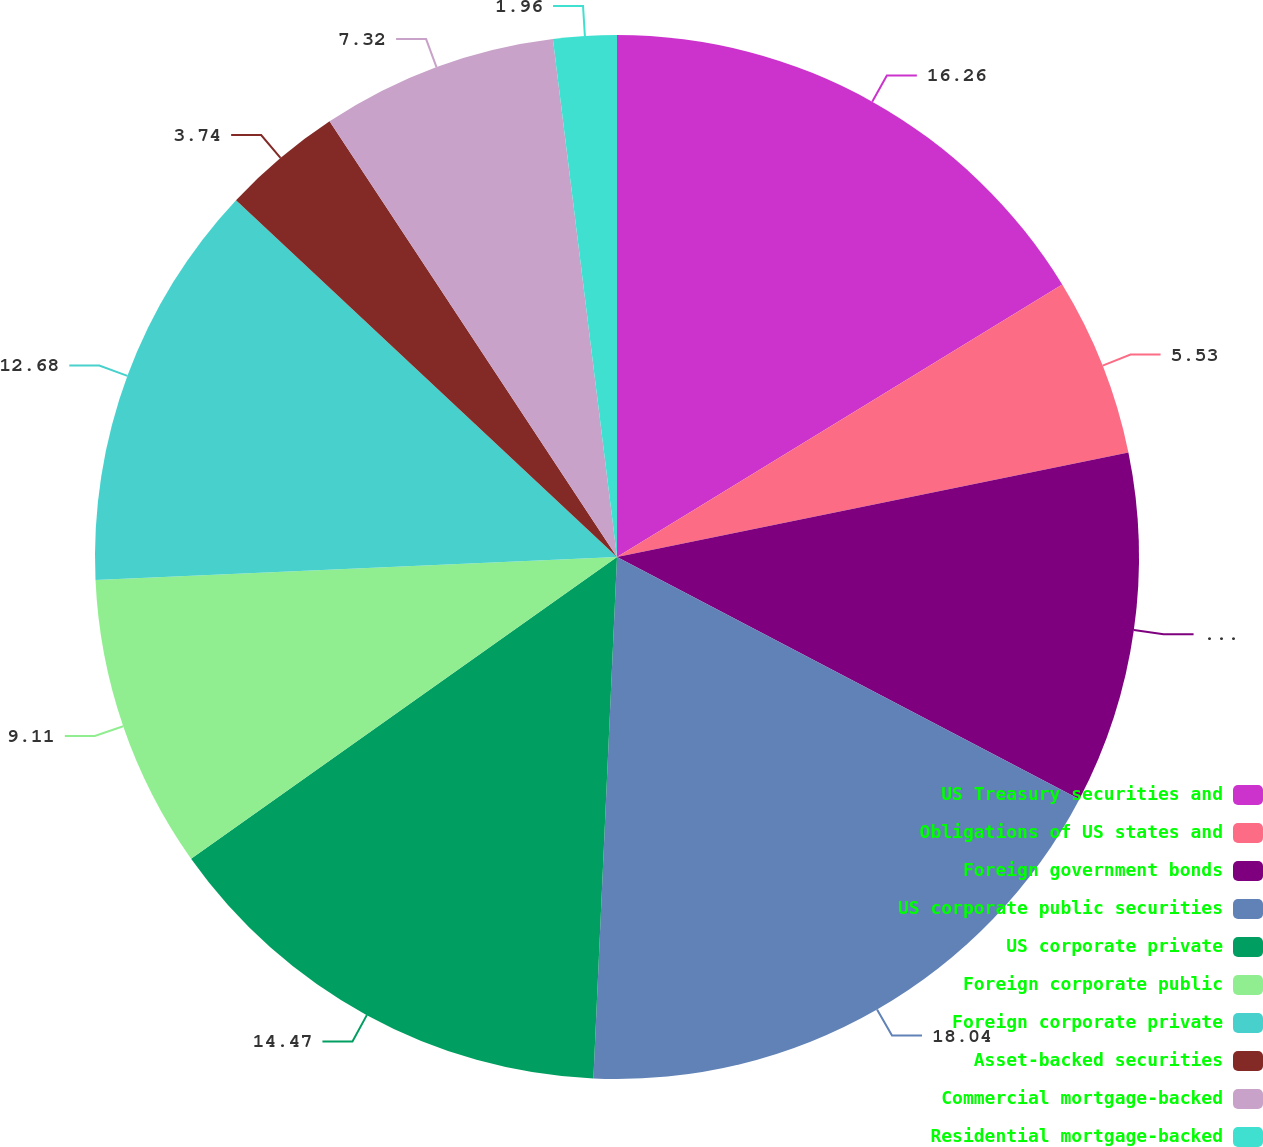<chart> <loc_0><loc_0><loc_500><loc_500><pie_chart><fcel>US Treasury securities and<fcel>Obligations of US states and<fcel>Foreign government bonds<fcel>US corporate public securities<fcel>US corporate private<fcel>Foreign corporate public<fcel>Foreign corporate private<fcel>Asset-backed securities<fcel>Commercial mortgage-backed<fcel>Residential mortgage-backed<nl><fcel>16.26%<fcel>5.53%<fcel>10.89%<fcel>18.04%<fcel>14.47%<fcel>9.11%<fcel>12.68%<fcel>3.74%<fcel>7.32%<fcel>1.96%<nl></chart> 